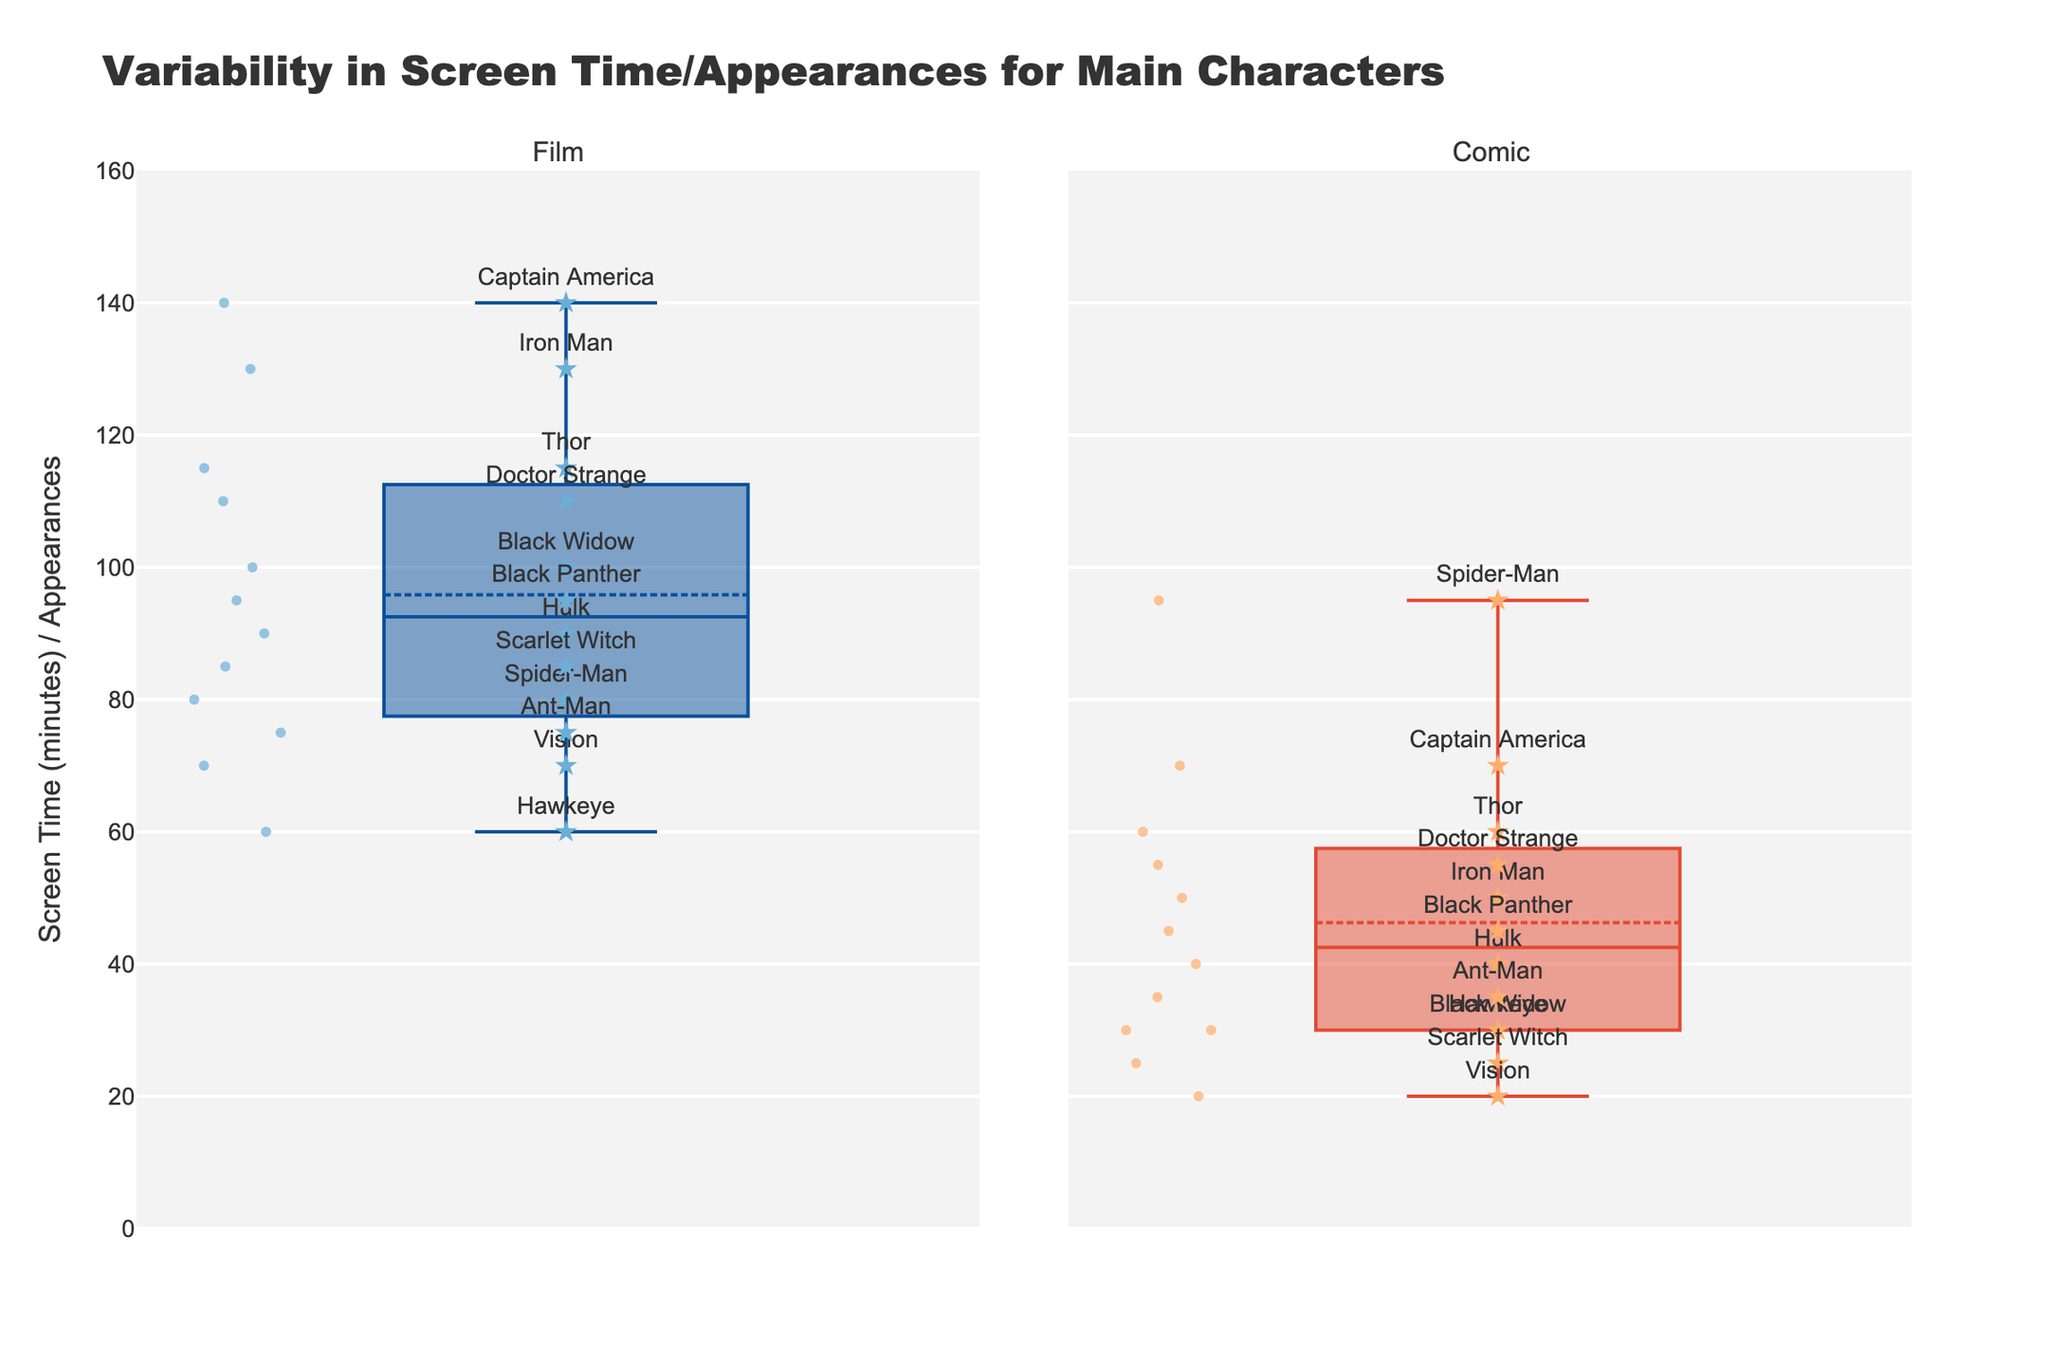what is the title of the plot? The title is displayed at the top of the plot and summarizes what the plot illustrates. It provides context to the viewer about what data is being visualized.
Answer: Variability in Screen Time/Appearances for Main Characters What is the range of the y-axis in the plot? The y-axis range is indicated on the left side of the plot. It shows the minimum and maximum values that the data points can take. In this case, it ranges from 0 to 160.
Answer: 0 to 160 Which character appears the most in the films based on the scatter points? By looking at the scatter points in the Film box plot, the character with the highest value represents the one with the most screen time. Captain America is shown at 140 minutes, the highest value in the Film category.
Answer: Captain America How does Black Widow's screen time in films compare to her appearances in comics? To compare Black Widow's data points, check her Film and Comic scatter points. In films, she has 100 minutes of screen time, while in comics, she has 30 appearances.
Answer: 100 (Film), 30 (Comic) Which medium has a higher median value: Films or Comics? The median value can be found as the central line in each box plot. For the Film plot, the median is higher than the Comics plot.
Answer: Films Are there any characters whose appearances in comics are higher than their screen time in films? By checking each character's scatter points in both plots, only Spider-Man has more comic appearances (95) than film screen time (80).
Answer: Spider-Man What's the average screen time for all characters in films? To find the average, sum up all the film screen times: 130 + 140 + 115 + 100 + 90 + 60 + 80 + 110 + 95 + 85 + 70 + 75 = 1250. There are 12 characters, so the average is 1250/12.
Answer: 104.17 What can you infer about the variability in characters' screen times in films versus their appearances in comics? By looking at the spread of the box plots and individual scatter points, the variability in films looks greater, with wider spread and more outliers than in comics.
Answer: Greater variability in films 